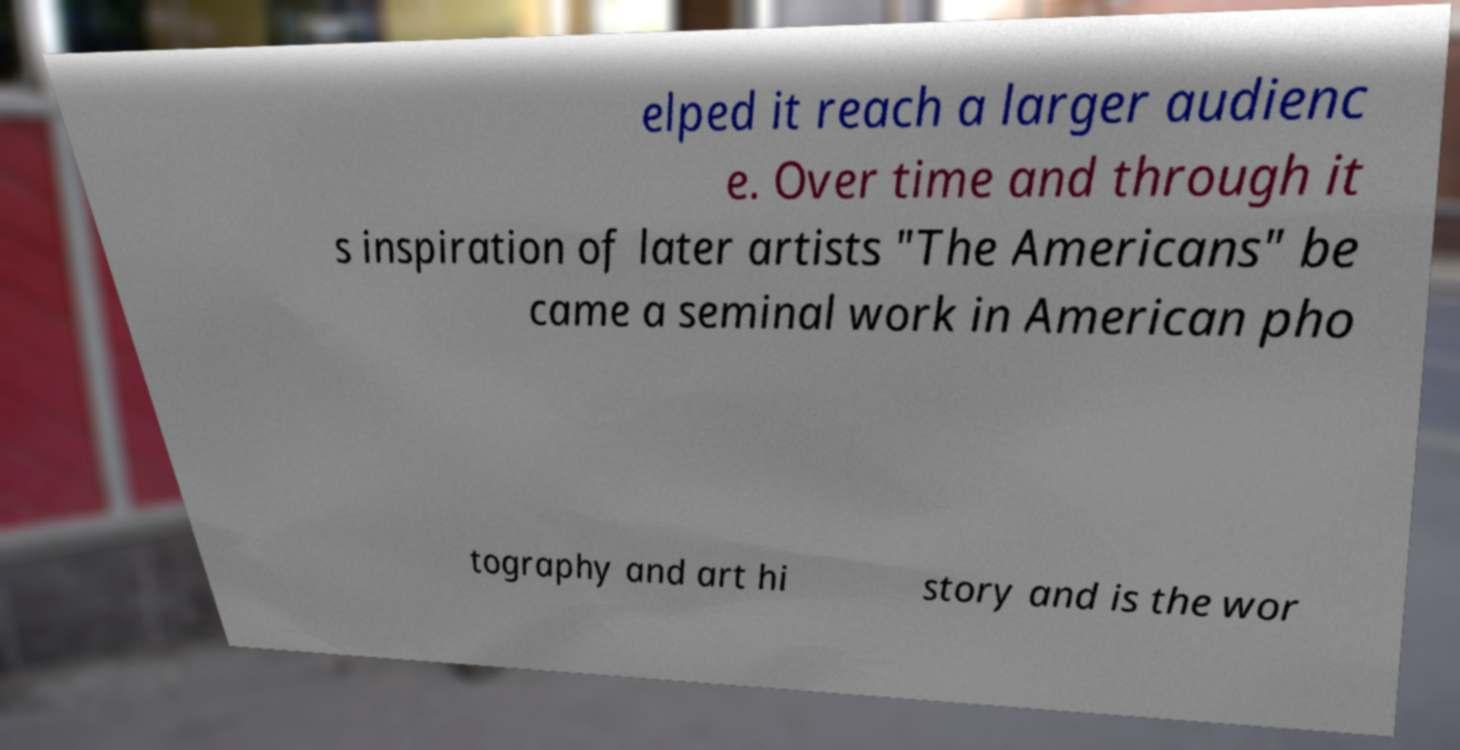For documentation purposes, I need the text within this image transcribed. Could you provide that? elped it reach a larger audienc e. Over time and through it s inspiration of later artists "The Americans" be came a seminal work in American pho tography and art hi story and is the wor 